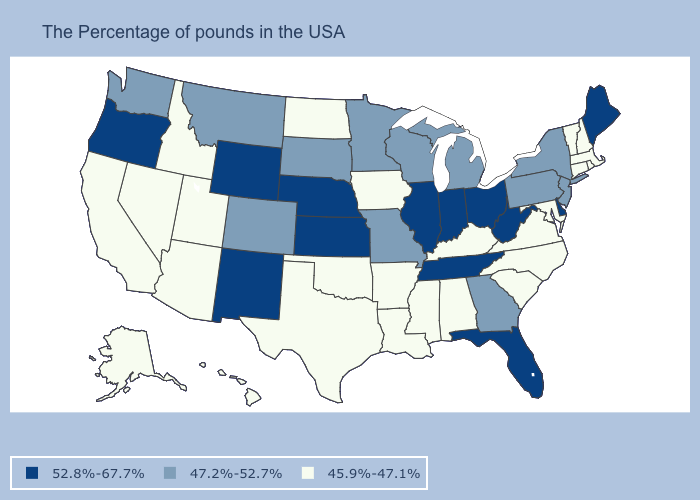Does South Dakota have the lowest value in the MidWest?
Answer briefly. No. Is the legend a continuous bar?
Give a very brief answer. No. What is the highest value in states that border New Hampshire?
Quick response, please. 52.8%-67.7%. How many symbols are there in the legend?
Short answer required. 3. Among the states that border Maine , which have the lowest value?
Keep it brief. New Hampshire. What is the value of New Hampshire?
Write a very short answer. 45.9%-47.1%. Is the legend a continuous bar?
Write a very short answer. No. Does Oregon have the lowest value in the West?
Give a very brief answer. No. Is the legend a continuous bar?
Quick response, please. No. Name the states that have a value in the range 52.8%-67.7%?
Concise answer only. Maine, Delaware, West Virginia, Ohio, Florida, Indiana, Tennessee, Illinois, Kansas, Nebraska, Wyoming, New Mexico, Oregon. What is the highest value in the MidWest ?
Short answer required. 52.8%-67.7%. What is the value of Arkansas?
Concise answer only. 45.9%-47.1%. What is the highest value in the USA?
Keep it brief. 52.8%-67.7%. Does the first symbol in the legend represent the smallest category?
Answer briefly. No. Does Delaware have a higher value than Nebraska?
Answer briefly. No. 